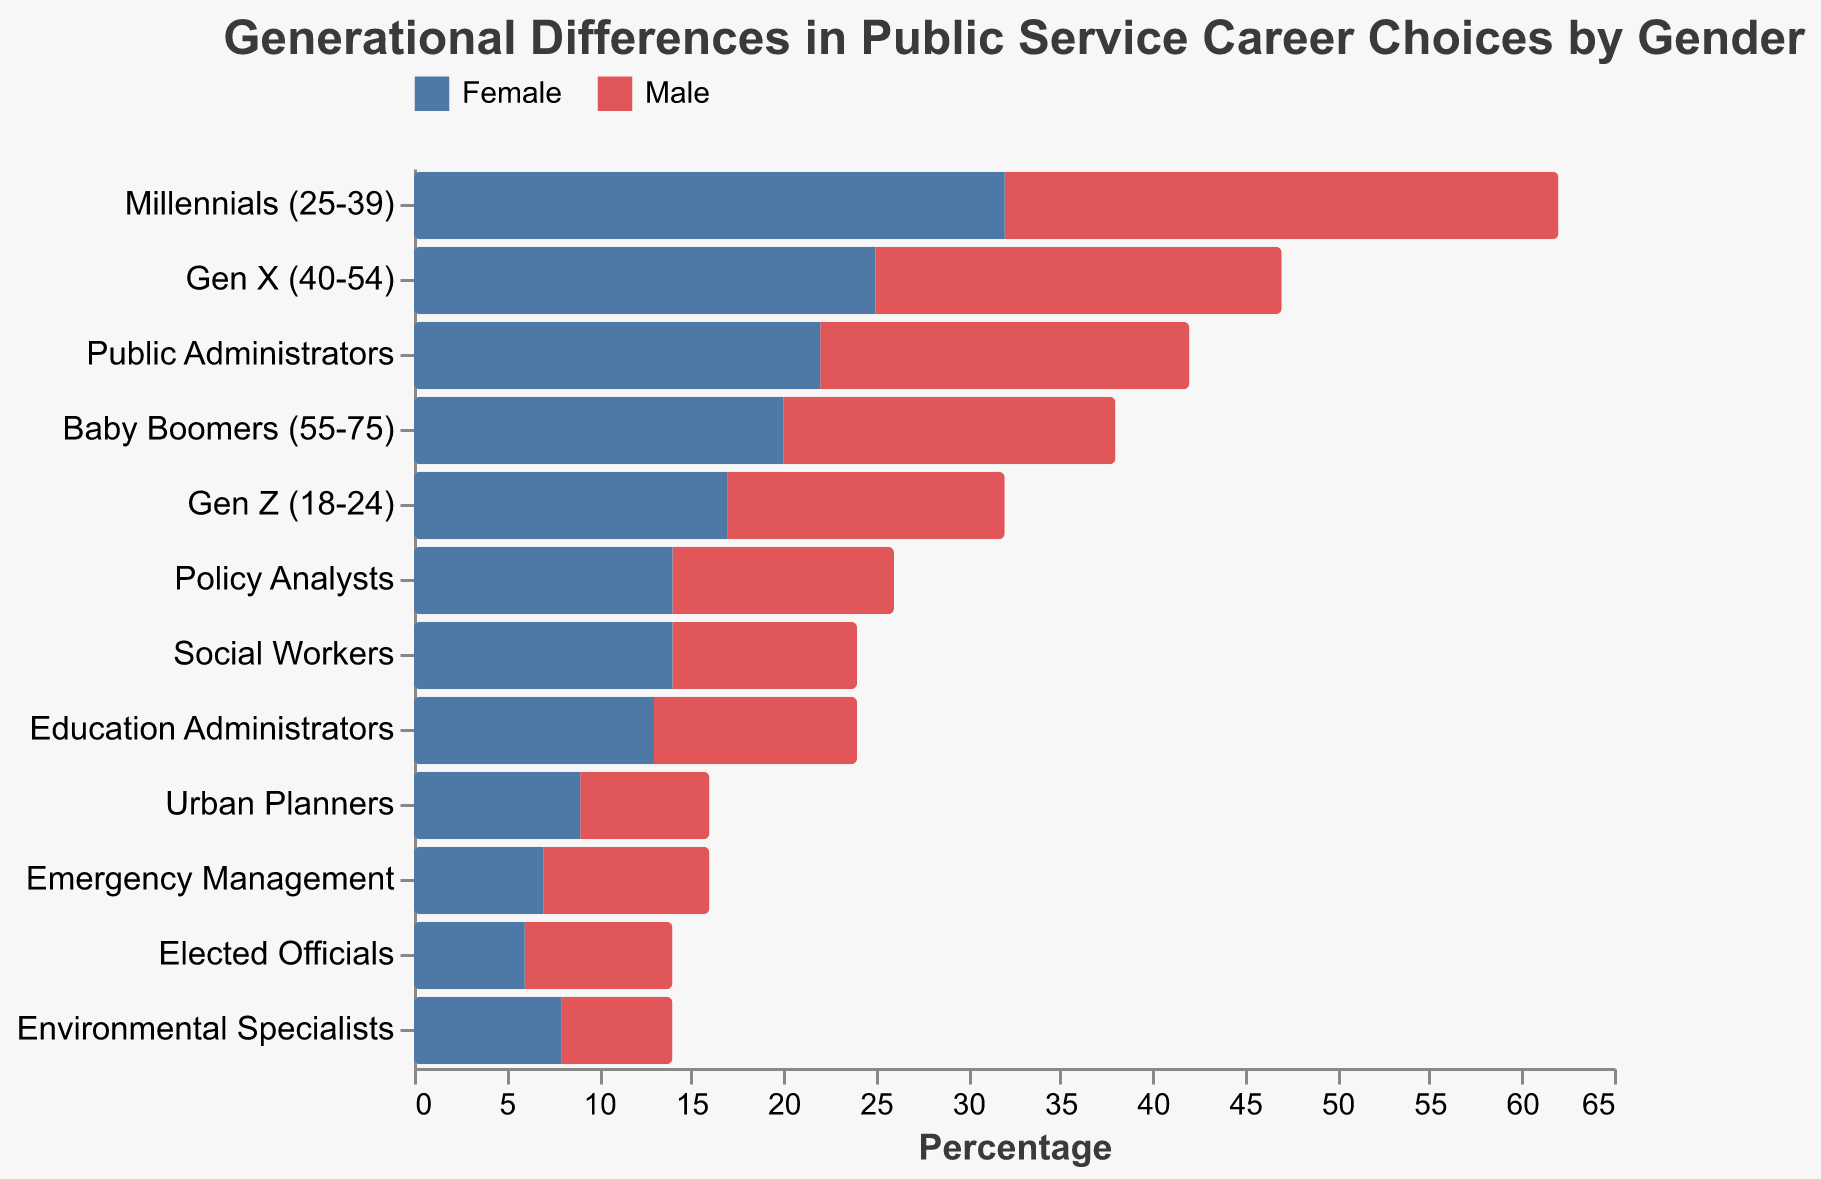What's the title of the figure? The title is displayed at the top of the figure. It reads "Generational Differences in Public Service Career Choices by Gender".
Answer: Generational Differences in Public Service Career Choices by Gender How many age/role categories are shown in the figure? Count the number of unique categories listed on the y-axis. The categories include Baby Boomers, Gen X, Millennials, Gen Z, and various public service roles totaling 12.
Answer: 12 Which gender has more Millennials (25-39) in public service? Look at the bars representing the Millennials (25-39) category. The male bar is longer than the female bar.
Answer: Male Are there more male or female Emergency Management professionals? Compare the lengths of the bars in the Emergency Management category. The male bar is longer than the female bar.
Answer: Male Which age group has the highest number of females in public service? Look at the negative values (indicating females) and compare their lengths. The Millennials (25-39) have the largest negative value at -32%.
Answer: Millennials (25-39) What is the sum of males in the Baby Boomers (55-75) and Gen Z (18-24) categories? Add the values for males in these age groups: 18 (Baby Boomers) + 15 (Gen Z) = 33.
Answer: 33 Which public service role shows the smallest difference in gender representation? Compare the bars for each role. Emergency Management shows the closest values for male (9) and female (-7), with a difference of 2.
Answer: Emergency Management What is the total percentage of males across all public service roles? Sum the values for males in all roles: 8 + 12 + 20 + 10 + 7 + 9 + 6 + 11 = 83
Answer: 83 In which role do females constitute a higher percentage compared to males? For each role, compare the female values (negative) to the male values (positive). Females have higher values in Policy Analysts (-14) versus males (12).
Answer: Policy Analysts 